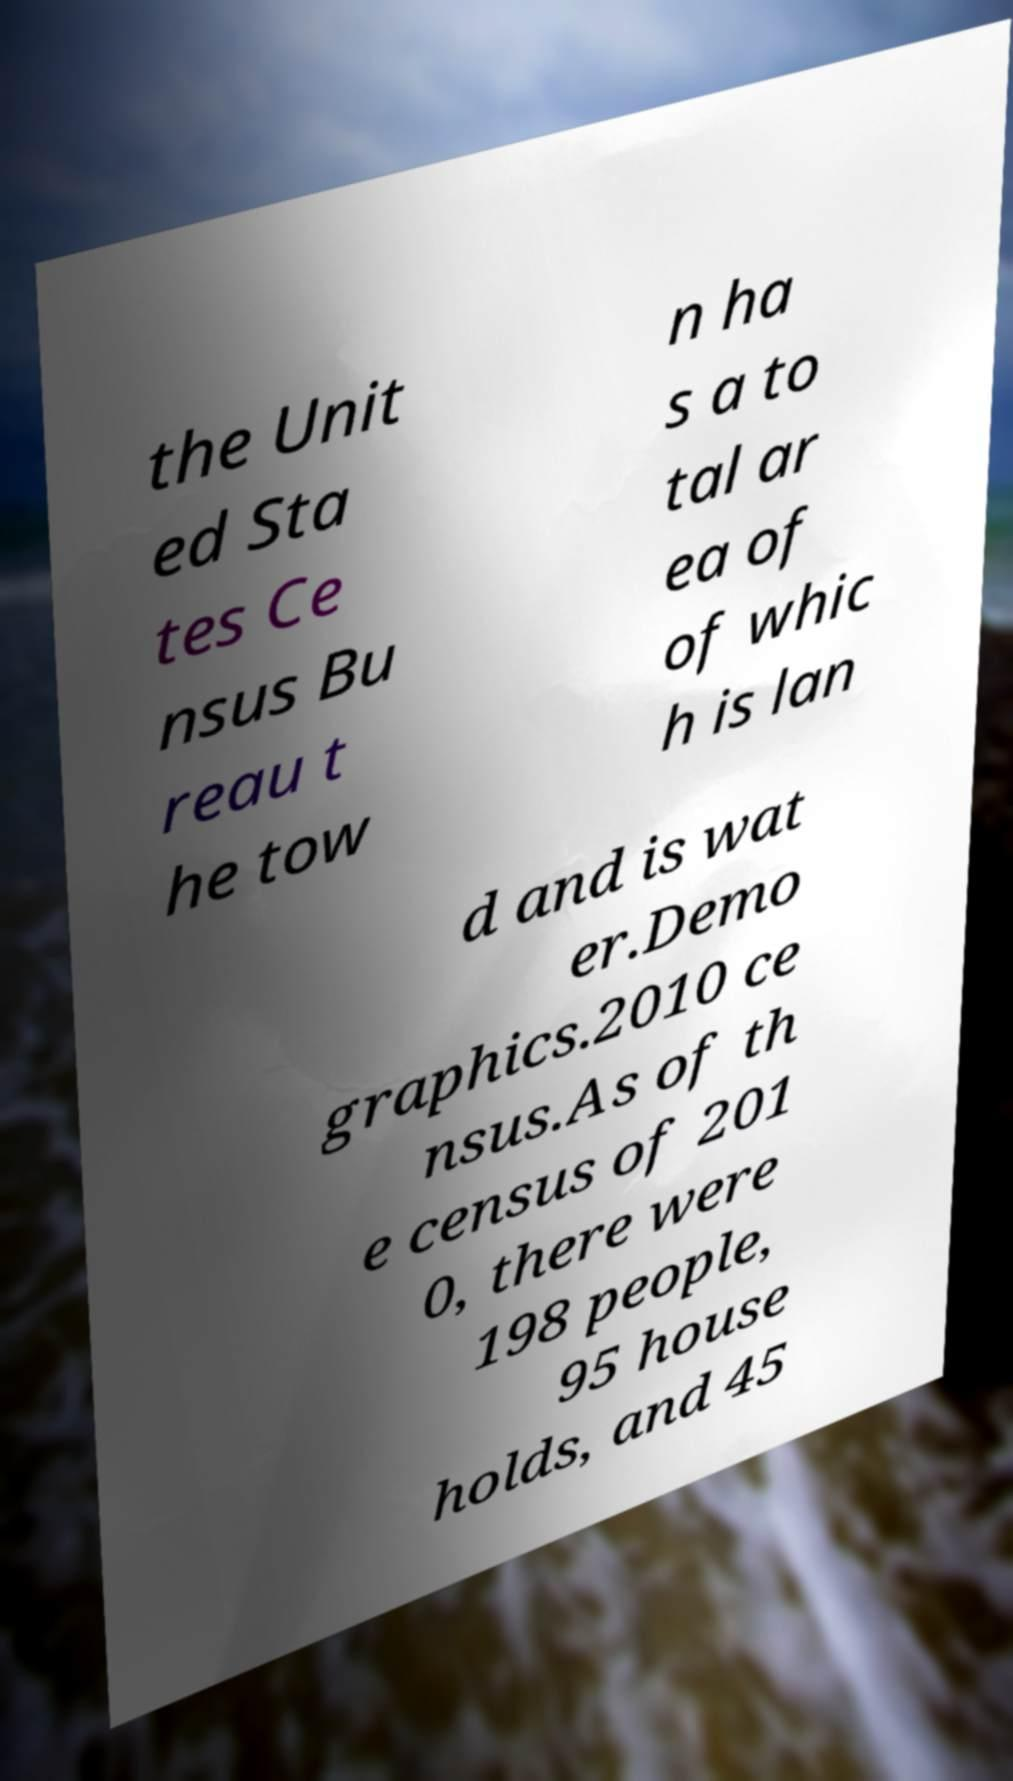Please identify and transcribe the text found in this image. the Unit ed Sta tes Ce nsus Bu reau t he tow n ha s a to tal ar ea of of whic h is lan d and is wat er.Demo graphics.2010 ce nsus.As of th e census of 201 0, there were 198 people, 95 house holds, and 45 